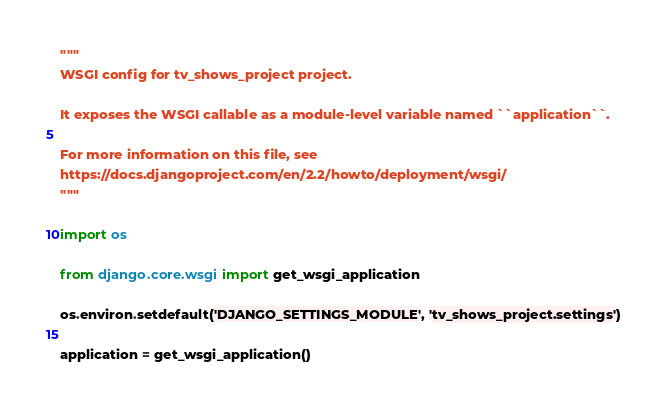<code> <loc_0><loc_0><loc_500><loc_500><_Python_>"""
WSGI config for tv_shows_project project.

It exposes the WSGI callable as a module-level variable named ``application``.

For more information on this file, see
https://docs.djangoproject.com/en/2.2/howto/deployment/wsgi/
"""

import os

from django.core.wsgi import get_wsgi_application

os.environ.setdefault('DJANGO_SETTINGS_MODULE', 'tv_shows_project.settings')

application = get_wsgi_application()
</code> 